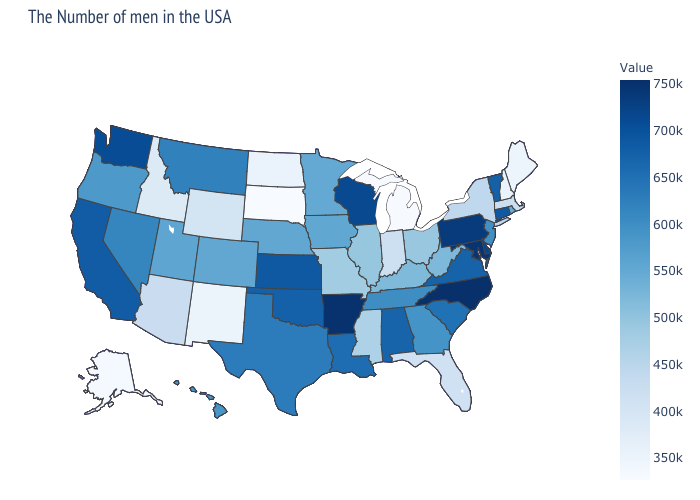Is the legend a continuous bar?
Be succinct. Yes. Does Indiana have a higher value than Alaska?
Keep it brief. Yes. Is the legend a continuous bar?
Keep it brief. Yes. Among the states that border South Dakota , does Minnesota have the lowest value?
Concise answer only. No. Does North Carolina have the highest value in the USA?
Be succinct. Yes. 